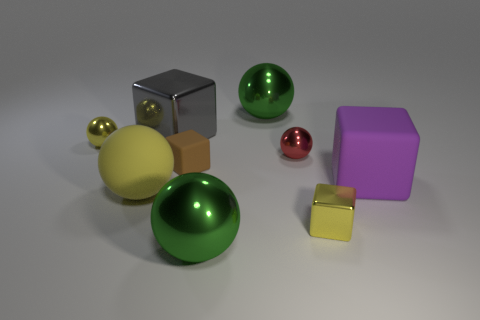How many yellow balls must be subtracted to get 1 yellow balls? 1 Subtract all brown cylinders. How many green spheres are left? 2 Subtract 1 cubes. How many cubes are left? 3 Subtract all yellow shiny spheres. How many spheres are left? 4 Subtract all yellow blocks. How many blocks are left? 3 Add 1 tiny brown cubes. How many objects exist? 10 Subtract all blocks. How many objects are left? 5 Subtract all green blocks. Subtract all yellow cylinders. How many blocks are left? 4 Add 7 tiny red metal spheres. How many tiny red metal spheres exist? 8 Subtract 0 green cubes. How many objects are left? 9 